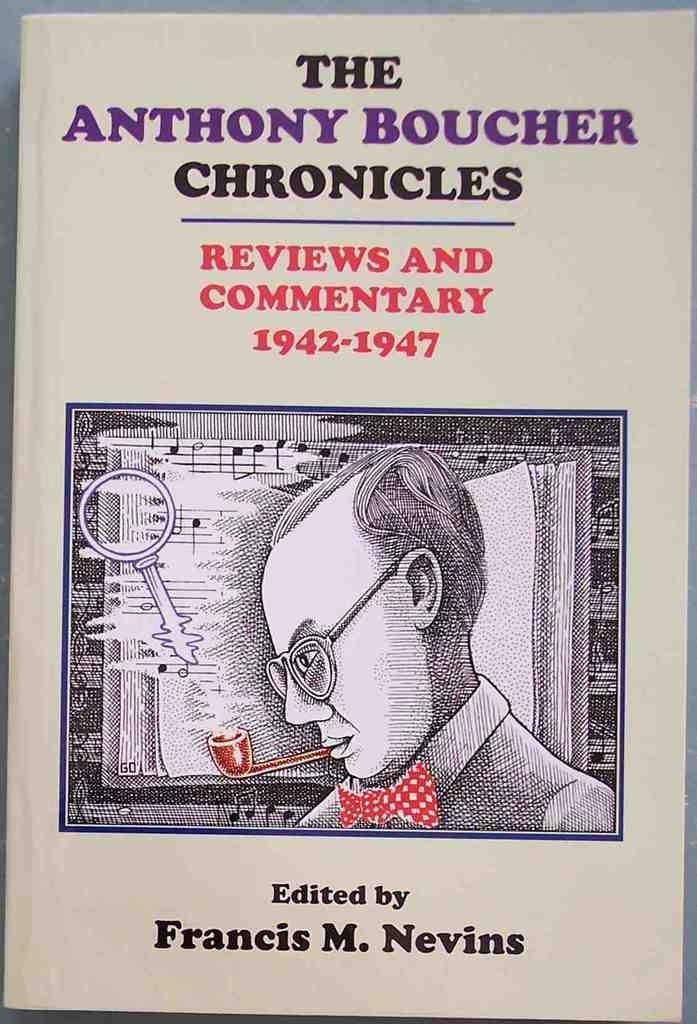<image>
Offer a succinct explanation of the picture presented. A book of Reviews and Commentary by Anthony Boucher. 